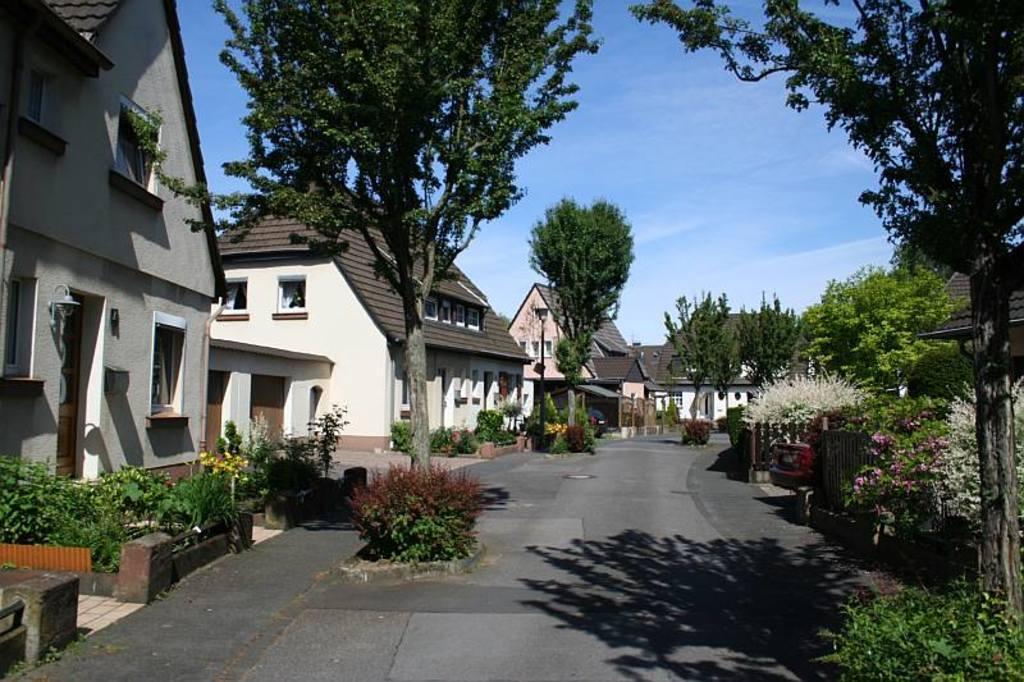Can you describe this image briefly? In this picture there are houses in the center of the image and there are trees and flower plants in the image. 